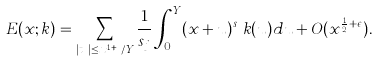<formula> <loc_0><loc_0><loc_500><loc_500>E ( x ; k ) = \sum _ { | t _ { j } | \leq x ^ { 1 + \epsilon } / Y } \frac { 1 } { s _ { j } } \int _ { 0 } ^ { Y } ( x + u ) ^ { s _ { j } } k ( u ) d u + O ( x ^ { \frac { 1 } { 2 } + \epsilon } ) .</formula> 